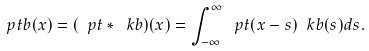<formula> <loc_0><loc_0><loc_500><loc_500>\ p t b ( x ) = ( \ p t * \ k b ) ( x ) = \int _ { - \infty } ^ { \infty } \ p t ( x - s ) \ k b ( s ) d s .</formula> 